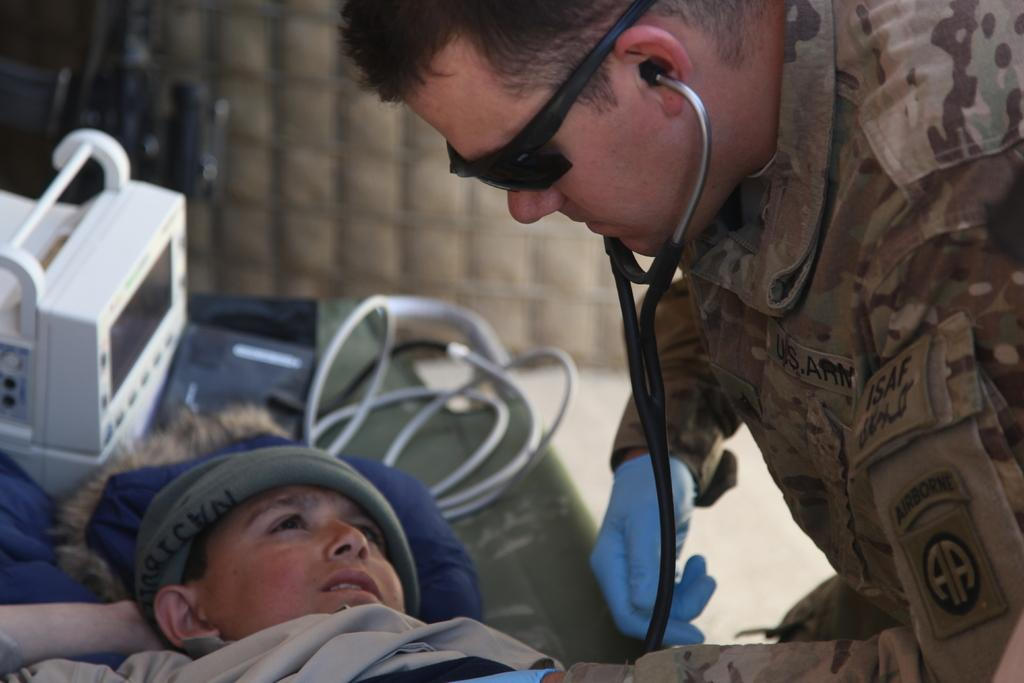How many people are in the image? There are two persons in the image. What is the position of one of the persons? One person is lying on a table. What else can be seen on the table besides the person? There are objects placed on the table. Where is the bat playing in the image? There is no bat or any indication of a bat playing in the image. 